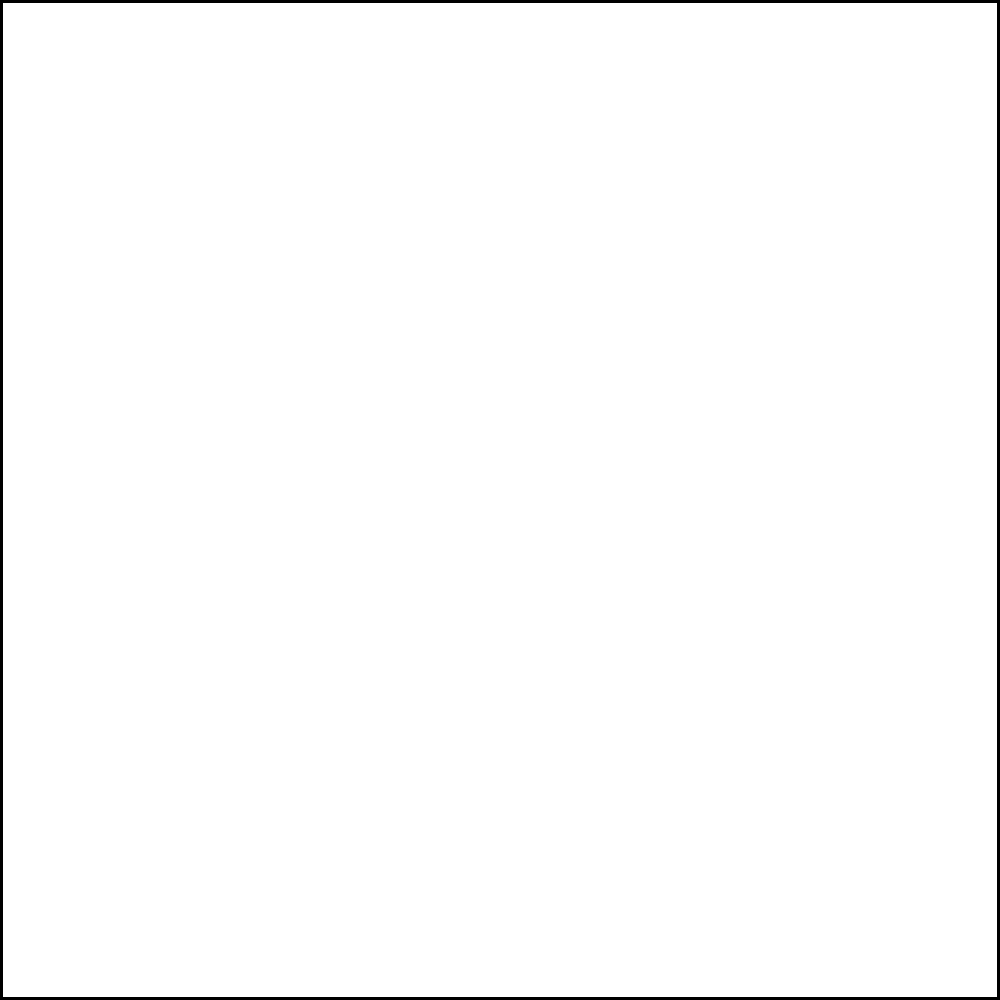As a metal supplier focused on quantity, you need to estimate the amount of circular metal sheets that can be cut from square plates. Given a square plate with side length 4 units, what is the circumference of the largest circular sheet that can be cut from it? Round your answer to the nearest whole number to maximize production efficiency. Let's approach this step-by-step:

1) The largest circle that can be inscribed in a square will touch the square at the midpoints of each side.

2) The diameter of this circle will be equal to the side length of the square. In this case, the diameter is 4 units.

3) The radius of the circle is half of the diameter:
   $r = \frac{4}{2} = 2$ units

4) The formula for the circumference of a circle is:
   $C = 2\pi r$

5) Substituting our radius:
   $C = 2\pi(2) = 4\pi$ units

6) Calculate:
   $4\pi \approx 12.5664$ units

7) Rounding to the nearest whole number to maximize production efficiency:
   $12.5664 \approx 13$ units
Answer: 13 units 